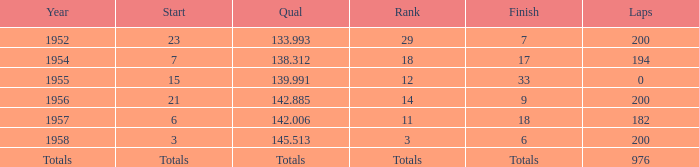What place did Jimmy Reece start from when he ranked 12? 15.0. 